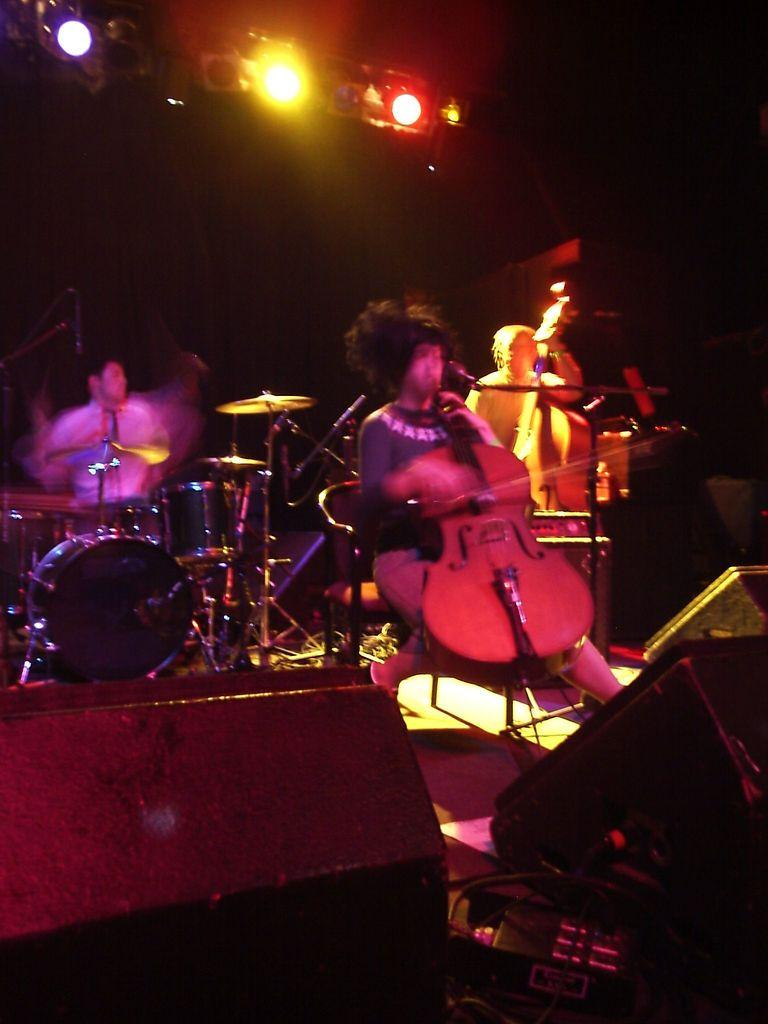What are the people in the image doing? The people in the image are playing musical instruments. Where are the musical instruments located in relation to the people? The musical instruments are in front of the people. What else can be seen in the image besides the people and musical instruments? There are speakers and lights present in the image. How many grapes are on the train in the image? There is no train or grapes present in the image. Is the family sitting together in the image? There is no family or indication of a family gathering in the image. 